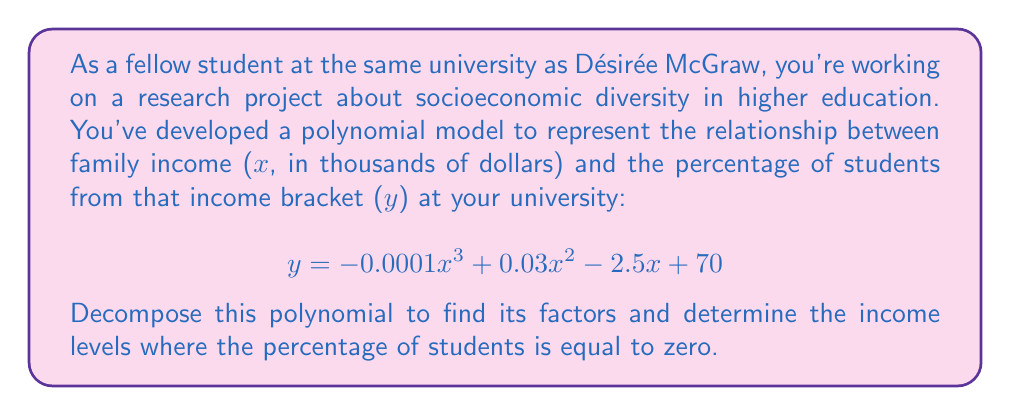Help me with this question. To solve this problem, we need to factor the polynomial and find its roots. Let's approach this step-by-step:

1) First, let's set the polynomial equal to zero:
   $$-0.0001x^3 + 0.03x^2 - 2.5x + 70 = 0$$

2) To make the coefficients easier to work with, let's multiply everything by 10000:
   $$-x^3 + 300x^2 - 25000x + 700000 = 0$$

3) This is a cubic equation. Let's try to guess one of its roots. By inspection or trial and error, we can find that x = 100 is a solution.

4) Using polynomial long division or the factor theorem, we can divide the polynomial by (x - 100):
   $$(x - 100)(-x^2 + 200x - 7000) = 0$$

5) Now we have a quadratic equation to solve: $-x^2 + 200x - 7000 = 0$

6) We can solve this using the quadratic formula: $x = \frac{-b \pm \sqrt{b^2 - 4ac}}{2a}$
   Where $a = -1$, $b = 200$, and $c = -7000$

7) Plugging in these values:
   $$x = \frac{-200 \pm \sqrt{200^2 - 4(-1)(-7000)}}{2(-1)}$$
   $$= \frac{-200 \pm \sqrt{40000 - 28000}}{-2}$$
   $$= \frac{-200 \pm \sqrt{12000}}{-2}$$
   $$= \frac{-200 \pm 2\sqrt{3000}}{-2}$$

8) This gives us two more solutions:
   $$x = 100 + \sqrt{3000}$$ and $$x = 100 - \sqrt{3000}$$

9) Therefore, the fully factored polynomial is:
   $$-0.0001(x - 100)(x - (100 + \sqrt{3000}))(x - (100 - \sqrt{3000}))$$

The roots of this polynomial represent the income levels where the percentage of students is zero.
Answer: The factored polynomial is:
$$-0.0001(x - 100)(x - (100 + \sqrt{3000}))(x - (100 - \sqrt{3000}))$$

The income levels where the percentage of students is zero are:
1) $100,000
2) $100,000 + \sqrt{3,000,000} \approx $154,772
3) $100,000 - \sqrt{3,000,000} \approx $45,228 